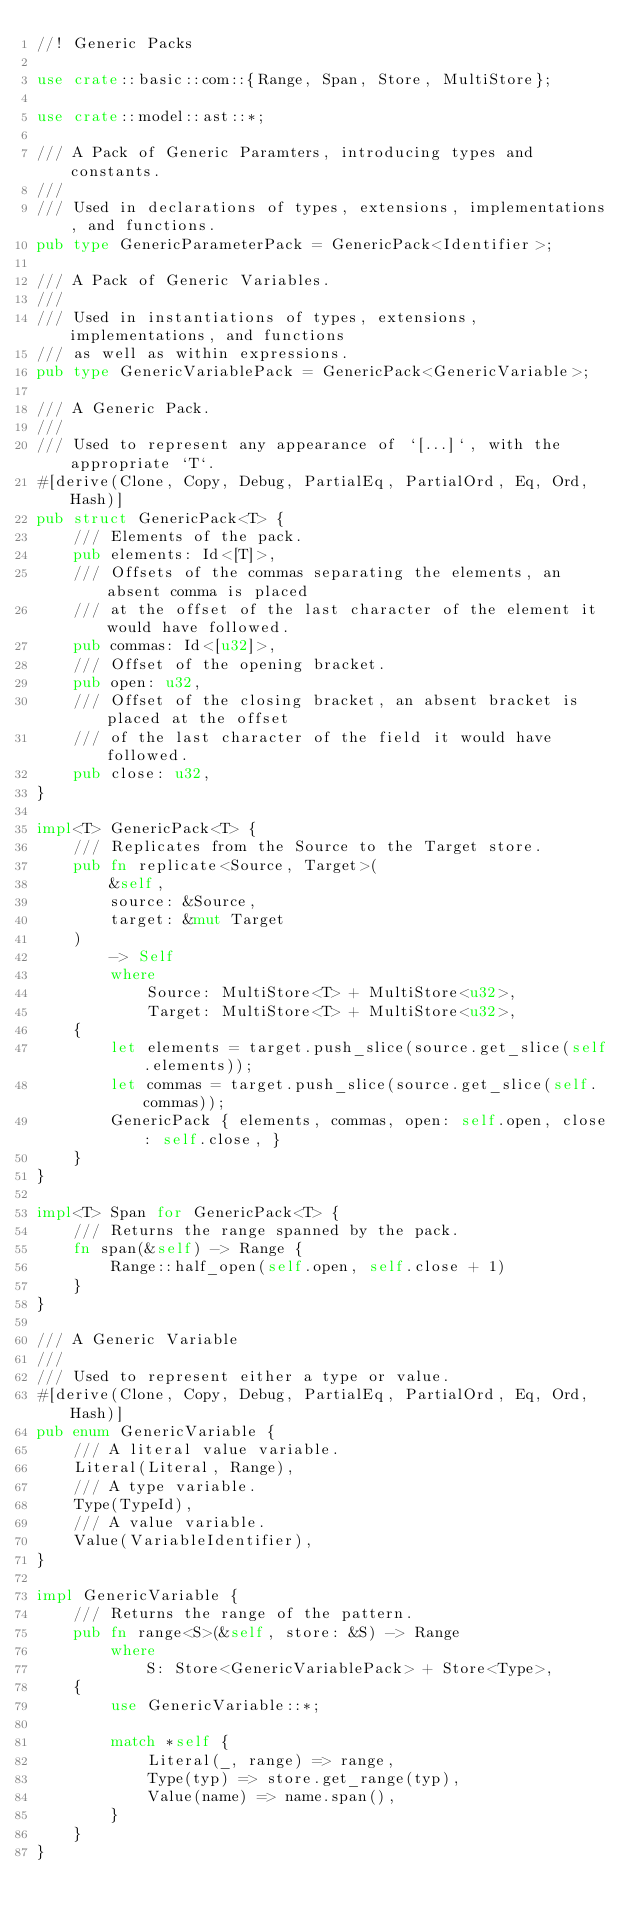Convert code to text. <code><loc_0><loc_0><loc_500><loc_500><_Rust_>//! Generic Packs

use crate::basic::com::{Range, Span, Store, MultiStore};

use crate::model::ast::*;

/// A Pack of Generic Paramters, introducing types and constants.
///
/// Used in declarations of types, extensions, implementations, and functions.
pub type GenericParameterPack = GenericPack<Identifier>;

/// A Pack of Generic Variables.
///
/// Used in instantiations of types, extensions, implementations, and functions
/// as well as within expressions.
pub type GenericVariablePack = GenericPack<GenericVariable>;

/// A Generic Pack.
///
/// Used to represent any appearance of `[...]`, with the appropriate `T`.
#[derive(Clone, Copy, Debug, PartialEq, PartialOrd, Eq, Ord, Hash)]
pub struct GenericPack<T> {
    /// Elements of the pack.
    pub elements: Id<[T]>,
    /// Offsets of the commas separating the elements, an absent comma is placed
    /// at the offset of the last character of the element it would have followed.
    pub commas: Id<[u32]>,
    /// Offset of the opening bracket.
    pub open: u32,
    /// Offset of the closing bracket, an absent bracket is placed at the offset
    /// of the last character of the field it would have followed.
    pub close: u32,
}

impl<T> GenericPack<T> {
    /// Replicates from the Source to the Target store.
    pub fn replicate<Source, Target>(
        &self,
        source: &Source,
        target: &mut Target
    )
        -> Self
        where
            Source: MultiStore<T> + MultiStore<u32>,
            Target: MultiStore<T> + MultiStore<u32>,
    {
        let elements = target.push_slice(source.get_slice(self.elements));
        let commas = target.push_slice(source.get_slice(self.commas));
        GenericPack { elements, commas, open: self.open, close: self.close, }
    }
}

impl<T> Span for GenericPack<T> {
    /// Returns the range spanned by the pack.
    fn span(&self) -> Range {
        Range::half_open(self.open, self.close + 1)
    }
}

/// A Generic Variable
///
/// Used to represent either a type or value.
#[derive(Clone, Copy, Debug, PartialEq, PartialOrd, Eq, Ord, Hash)]
pub enum GenericVariable {
    /// A literal value variable.
    Literal(Literal, Range),
    /// A type variable.
    Type(TypeId),
    /// A value variable.
    Value(VariableIdentifier),
}

impl GenericVariable {
    /// Returns the range of the pattern.
    pub fn range<S>(&self, store: &S) -> Range
        where
            S: Store<GenericVariablePack> + Store<Type>,
    {
        use GenericVariable::*;

        match *self {
            Literal(_, range) => range,
            Type(typ) => store.get_range(typ),
            Value(name) => name.span(),
        }
    }
}
</code> 